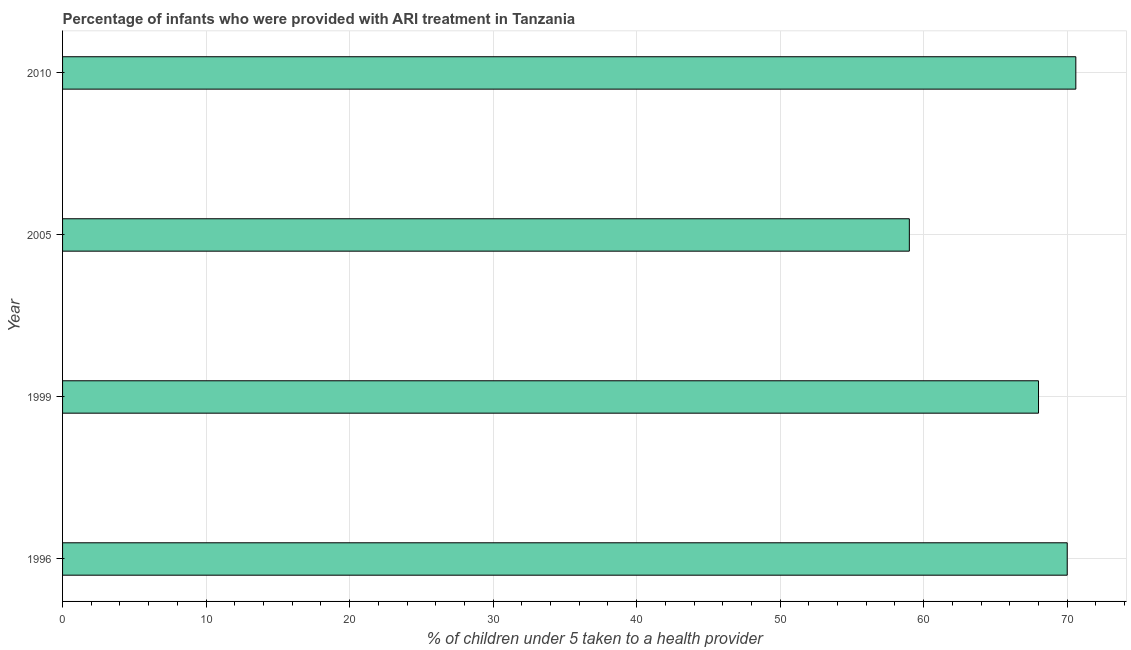Does the graph contain grids?
Your answer should be very brief. Yes. What is the title of the graph?
Give a very brief answer. Percentage of infants who were provided with ARI treatment in Tanzania. What is the label or title of the X-axis?
Provide a short and direct response. % of children under 5 taken to a health provider. What is the label or title of the Y-axis?
Offer a terse response. Year. Across all years, what is the maximum percentage of children who were provided with ari treatment?
Provide a succinct answer. 70.6. Across all years, what is the minimum percentage of children who were provided with ari treatment?
Ensure brevity in your answer.  59. In which year was the percentage of children who were provided with ari treatment maximum?
Give a very brief answer. 2010. In which year was the percentage of children who were provided with ari treatment minimum?
Offer a terse response. 2005. What is the sum of the percentage of children who were provided with ari treatment?
Offer a very short reply. 267.6. What is the difference between the percentage of children who were provided with ari treatment in 1999 and 2005?
Provide a short and direct response. 9. What is the average percentage of children who were provided with ari treatment per year?
Make the answer very short. 66.9. What is the median percentage of children who were provided with ari treatment?
Your answer should be compact. 69. In how many years, is the percentage of children who were provided with ari treatment greater than 12 %?
Your answer should be compact. 4. Do a majority of the years between 2010 and 2005 (inclusive) have percentage of children who were provided with ari treatment greater than 58 %?
Ensure brevity in your answer.  No. What is the ratio of the percentage of children who were provided with ari treatment in 2005 to that in 2010?
Provide a short and direct response. 0.84. Is the difference between the percentage of children who were provided with ari treatment in 1999 and 2005 greater than the difference between any two years?
Offer a very short reply. No. Is the sum of the percentage of children who were provided with ari treatment in 2005 and 2010 greater than the maximum percentage of children who were provided with ari treatment across all years?
Offer a terse response. Yes. What is the difference between the highest and the lowest percentage of children who were provided with ari treatment?
Give a very brief answer. 11.6. In how many years, is the percentage of children who were provided with ari treatment greater than the average percentage of children who were provided with ari treatment taken over all years?
Your answer should be very brief. 3. How many bars are there?
Your answer should be compact. 4. Are all the bars in the graph horizontal?
Your answer should be very brief. Yes. How many years are there in the graph?
Your answer should be compact. 4. What is the % of children under 5 taken to a health provider of 1999?
Offer a terse response. 68. What is the % of children under 5 taken to a health provider of 2010?
Provide a short and direct response. 70.6. What is the difference between the % of children under 5 taken to a health provider in 1996 and 1999?
Provide a short and direct response. 2. What is the difference between the % of children under 5 taken to a health provider in 1996 and 2010?
Keep it short and to the point. -0.6. What is the difference between the % of children under 5 taken to a health provider in 1999 and 2010?
Ensure brevity in your answer.  -2.6. What is the ratio of the % of children under 5 taken to a health provider in 1996 to that in 1999?
Ensure brevity in your answer.  1.03. What is the ratio of the % of children under 5 taken to a health provider in 1996 to that in 2005?
Your answer should be compact. 1.19. What is the ratio of the % of children under 5 taken to a health provider in 1996 to that in 2010?
Make the answer very short. 0.99. What is the ratio of the % of children under 5 taken to a health provider in 1999 to that in 2005?
Offer a terse response. 1.15. What is the ratio of the % of children under 5 taken to a health provider in 2005 to that in 2010?
Your answer should be compact. 0.84. 